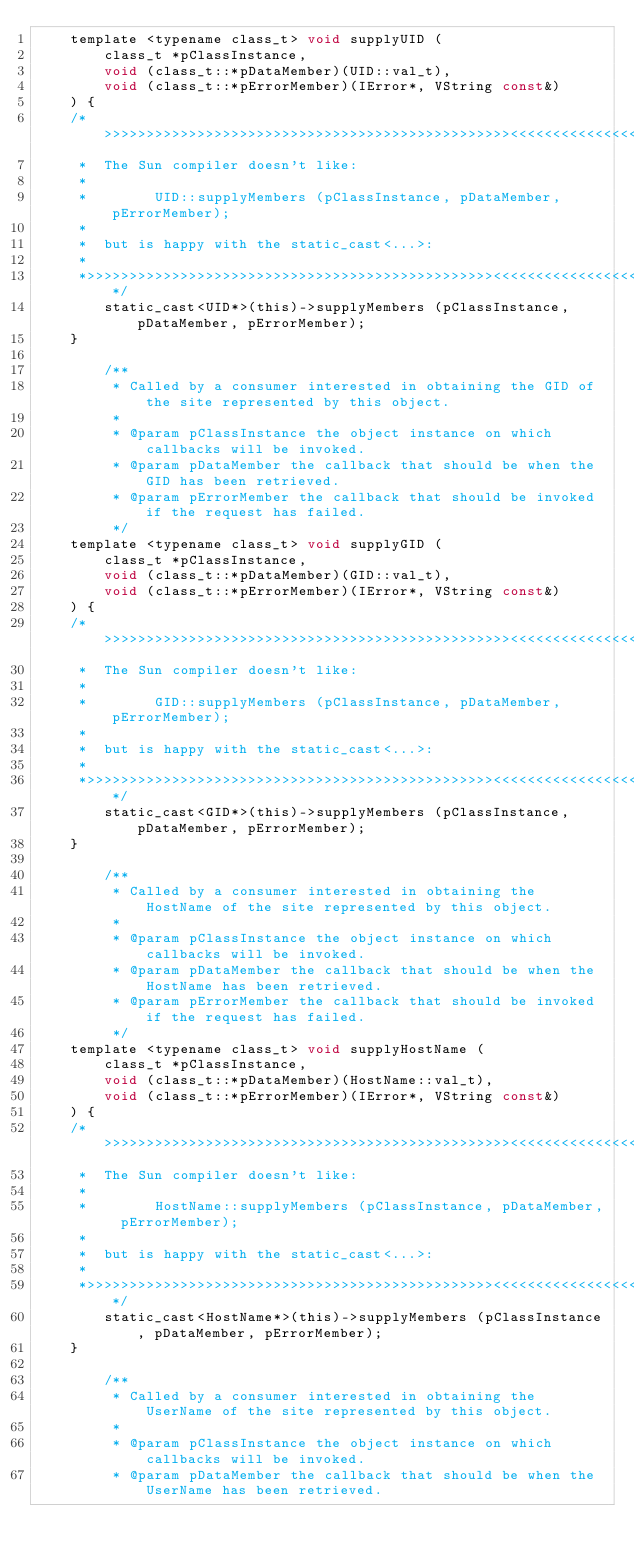<code> <loc_0><loc_0><loc_500><loc_500><_C_>	template <typename class_t> void supplyUID (
	    class_t *pClassInstance,
	    void (class_t::*pDataMember)(UID::val_t),
	    void (class_t::*pErrorMember)(IError*, VString const&)
	) {
	/*>>>>>>>>>>>>>>>>>>>>>>>>>>>>>>>>>>>>>>>>>>>>>>>><<<<<<<<<<<<<<<<<<<<<<<<<<<<<<<<<<<<<<<<<<<<<<<<*
	 *  The Sun compiler doesn't like:
	 *
	 *        UID::supplyMembers (pClassInstance, pDataMember, pErrorMember);
	 *
	 *  but is happy with the static_cast<...>:
	 *
	 *>>>>>>>>>>>>>>>>>>>>>>>>>>>>>>>>>>>>>>>>>>>>>>>><<<<<<<<<<<<<<<<<<<<<<<<<<<<<<<<<<<<<<<<<<<<<<<<*/
	    static_cast<UID*>(this)->supplyMembers (pClassInstance, pDataMember, pErrorMember);
	}

        /**
         * Called by a consumer interested in obtaining the GID of the site represented by this object.
         *
         * @param pClassInstance the object instance on which callbacks will be invoked.
         * @param pDataMember the callback that should be when the GID has been retrieved.
         * @param pErrorMember the callback that should be invoked if the request has failed.
         */
	template <typename class_t> void supplyGID (
	    class_t *pClassInstance,
	    void (class_t::*pDataMember)(GID::val_t),
	    void (class_t::*pErrorMember)(IError*, VString const&)
	) {
	/*>>>>>>>>>>>>>>>>>>>>>>>>>>>>>>>>>>>>>>>>>>>>>>>><<<<<<<<<<<<<<<<<<<<<<<<<<<<<<<<<<<<<<<<<<<<<<<<*
	 *  The Sun compiler doesn't like:
	 *
	 *        GID::supplyMembers (pClassInstance, pDataMember, pErrorMember);
	 *
	 *  but is happy with the static_cast<...>:
	 *
	 *>>>>>>>>>>>>>>>>>>>>>>>>>>>>>>>>>>>>>>>>>>>>>>>><<<<<<<<<<<<<<<<<<<<<<<<<<<<<<<<<<<<<<<<<<<<<<<<*/
	    static_cast<GID*>(this)->supplyMembers (pClassInstance, pDataMember, pErrorMember);
	}

        /**
         * Called by a consumer interested in obtaining the HostName of the site represented by this object.
         *
         * @param pClassInstance the object instance on which callbacks will be invoked.
         * @param pDataMember the callback that should be when the HostName has been retrieved.
         * @param pErrorMember the callback that should be invoked if the request has failed.
         */
	template <typename class_t> void supplyHostName (
	    class_t *pClassInstance,
	    void (class_t::*pDataMember)(HostName::val_t),
	    void (class_t::*pErrorMember)(IError*, VString const&)
	) {
	/*>>>>>>>>>>>>>>>>>>>>>>>>>>>>>>>>>>>>>>>>>>>>>>>><<<<<<<<<<<<<<<<<<<<<<<<<<<<<<<<<<<<<<<<<<<<<<<<*
	 *  The Sun compiler doesn't like:
	 *
	 *        HostName::supplyMembers (pClassInstance, pDataMember, pErrorMember);
	 *
	 *  but is happy with the static_cast<...>:
	 *
	 *>>>>>>>>>>>>>>>>>>>>>>>>>>>>>>>>>>>>>>>>>>>>>>>><<<<<<<<<<<<<<<<<<<<<<<<<<<<<<<<<<<<<<<<<<<<<<<<*/
	    static_cast<HostName*>(this)->supplyMembers (pClassInstance, pDataMember, pErrorMember);
	}

        /**
         * Called by a consumer interested in obtaining the UserName of the site represented by this object.
         *
         * @param pClassInstance the object instance on which callbacks will be invoked.
         * @param pDataMember the callback that should be when the UserName has been retrieved.</code> 